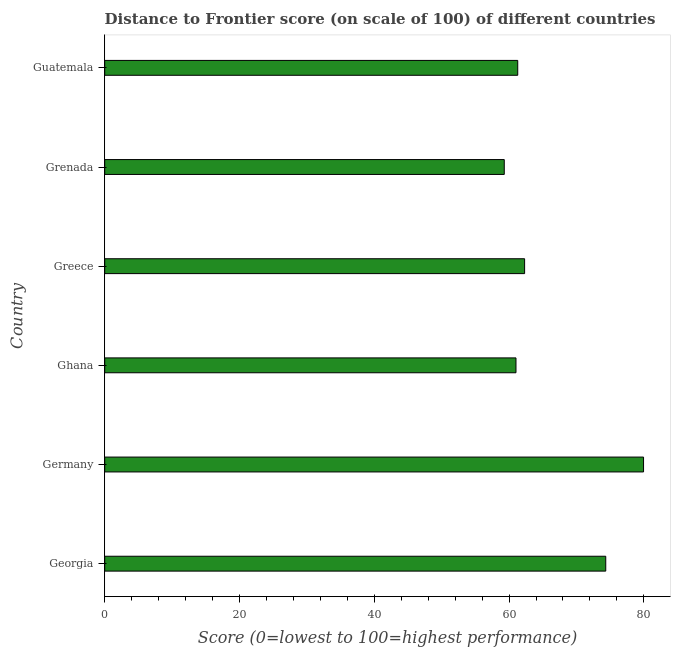Does the graph contain any zero values?
Provide a short and direct response. No. What is the title of the graph?
Keep it short and to the point. Distance to Frontier score (on scale of 100) of different countries. What is the label or title of the X-axis?
Your response must be concise. Score (0=lowest to 100=highest performance). What is the distance to frontier score in Guatemala?
Provide a succinct answer. 61.29. Across all countries, what is the maximum distance to frontier score?
Offer a terse response. 79.96. Across all countries, what is the minimum distance to frontier score?
Keep it short and to the point. 59.29. In which country was the distance to frontier score minimum?
Your answer should be compact. Grenada. What is the sum of the distance to frontier score?
Give a very brief answer. 398.23. What is the average distance to frontier score per country?
Provide a short and direct response. 66.37. What is the median distance to frontier score?
Provide a short and direct response. 61.8. What is the ratio of the distance to frontier score in Ghana to that in Greece?
Give a very brief answer. 0.98. Is the difference between the distance to frontier score in Grenada and Guatemala greater than the difference between any two countries?
Your response must be concise. No. What is the difference between the highest and the second highest distance to frontier score?
Offer a very short reply. 5.61. What is the difference between the highest and the lowest distance to frontier score?
Give a very brief answer. 20.67. In how many countries, is the distance to frontier score greater than the average distance to frontier score taken over all countries?
Offer a terse response. 2. How many bars are there?
Provide a short and direct response. 6. Are all the bars in the graph horizontal?
Offer a very short reply. Yes. What is the Score (0=lowest to 100=highest performance) of Georgia?
Ensure brevity in your answer.  74.35. What is the Score (0=lowest to 100=highest performance) in Germany?
Offer a terse response. 79.96. What is the Score (0=lowest to 100=highest performance) in Ghana?
Your answer should be very brief. 61.03. What is the Score (0=lowest to 100=highest performance) in Greece?
Provide a short and direct response. 62.31. What is the Score (0=lowest to 100=highest performance) in Grenada?
Your response must be concise. 59.29. What is the Score (0=lowest to 100=highest performance) of Guatemala?
Keep it short and to the point. 61.29. What is the difference between the Score (0=lowest to 100=highest performance) in Georgia and Germany?
Make the answer very short. -5.61. What is the difference between the Score (0=lowest to 100=highest performance) in Georgia and Ghana?
Offer a terse response. 13.32. What is the difference between the Score (0=lowest to 100=highest performance) in Georgia and Greece?
Make the answer very short. 12.04. What is the difference between the Score (0=lowest to 100=highest performance) in Georgia and Grenada?
Make the answer very short. 15.06. What is the difference between the Score (0=lowest to 100=highest performance) in Georgia and Guatemala?
Provide a short and direct response. 13.06. What is the difference between the Score (0=lowest to 100=highest performance) in Germany and Ghana?
Your answer should be very brief. 18.93. What is the difference between the Score (0=lowest to 100=highest performance) in Germany and Greece?
Provide a succinct answer. 17.65. What is the difference between the Score (0=lowest to 100=highest performance) in Germany and Grenada?
Make the answer very short. 20.67. What is the difference between the Score (0=lowest to 100=highest performance) in Germany and Guatemala?
Your answer should be very brief. 18.67. What is the difference between the Score (0=lowest to 100=highest performance) in Ghana and Greece?
Offer a very short reply. -1.28. What is the difference between the Score (0=lowest to 100=highest performance) in Ghana and Grenada?
Offer a very short reply. 1.74. What is the difference between the Score (0=lowest to 100=highest performance) in Ghana and Guatemala?
Provide a succinct answer. -0.26. What is the difference between the Score (0=lowest to 100=highest performance) in Greece and Grenada?
Provide a short and direct response. 3.02. What is the difference between the Score (0=lowest to 100=highest performance) in Greece and Guatemala?
Provide a short and direct response. 1.02. What is the ratio of the Score (0=lowest to 100=highest performance) in Georgia to that in Ghana?
Your answer should be compact. 1.22. What is the ratio of the Score (0=lowest to 100=highest performance) in Georgia to that in Greece?
Give a very brief answer. 1.19. What is the ratio of the Score (0=lowest to 100=highest performance) in Georgia to that in Grenada?
Make the answer very short. 1.25. What is the ratio of the Score (0=lowest to 100=highest performance) in Georgia to that in Guatemala?
Give a very brief answer. 1.21. What is the ratio of the Score (0=lowest to 100=highest performance) in Germany to that in Ghana?
Provide a short and direct response. 1.31. What is the ratio of the Score (0=lowest to 100=highest performance) in Germany to that in Greece?
Give a very brief answer. 1.28. What is the ratio of the Score (0=lowest to 100=highest performance) in Germany to that in Grenada?
Provide a succinct answer. 1.35. What is the ratio of the Score (0=lowest to 100=highest performance) in Germany to that in Guatemala?
Your answer should be compact. 1.3. What is the ratio of the Score (0=lowest to 100=highest performance) in Ghana to that in Greece?
Your response must be concise. 0.98. What is the ratio of the Score (0=lowest to 100=highest performance) in Ghana to that in Grenada?
Your answer should be very brief. 1.03. What is the ratio of the Score (0=lowest to 100=highest performance) in Greece to that in Grenada?
Your response must be concise. 1.05. What is the ratio of the Score (0=lowest to 100=highest performance) in Grenada to that in Guatemala?
Provide a short and direct response. 0.97. 